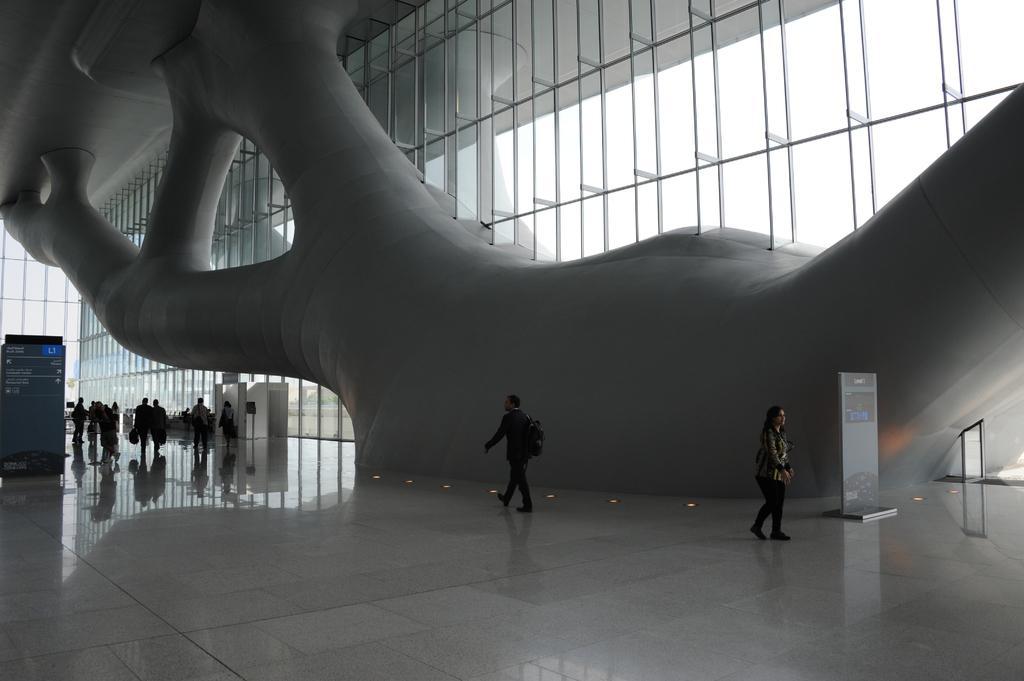How would you summarize this image in a sentence or two? In the picture we can see a inside the building, the building wall is with glass and inside it we can see a man and a woman are walking and far away from them we can see some people are walking here and there. 